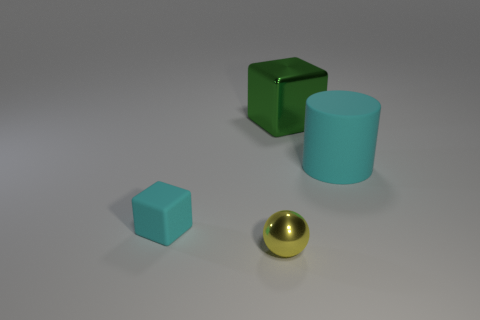How many objects are there and can you describe their shapes and colors? There are four objects in the image. Starting from the left, there is a small light blue cube, a medium-sized green cube, a large light blue cylinder, and a small metallic gold sphere. Each object has distinct geometrical features and are colored distinctly. 